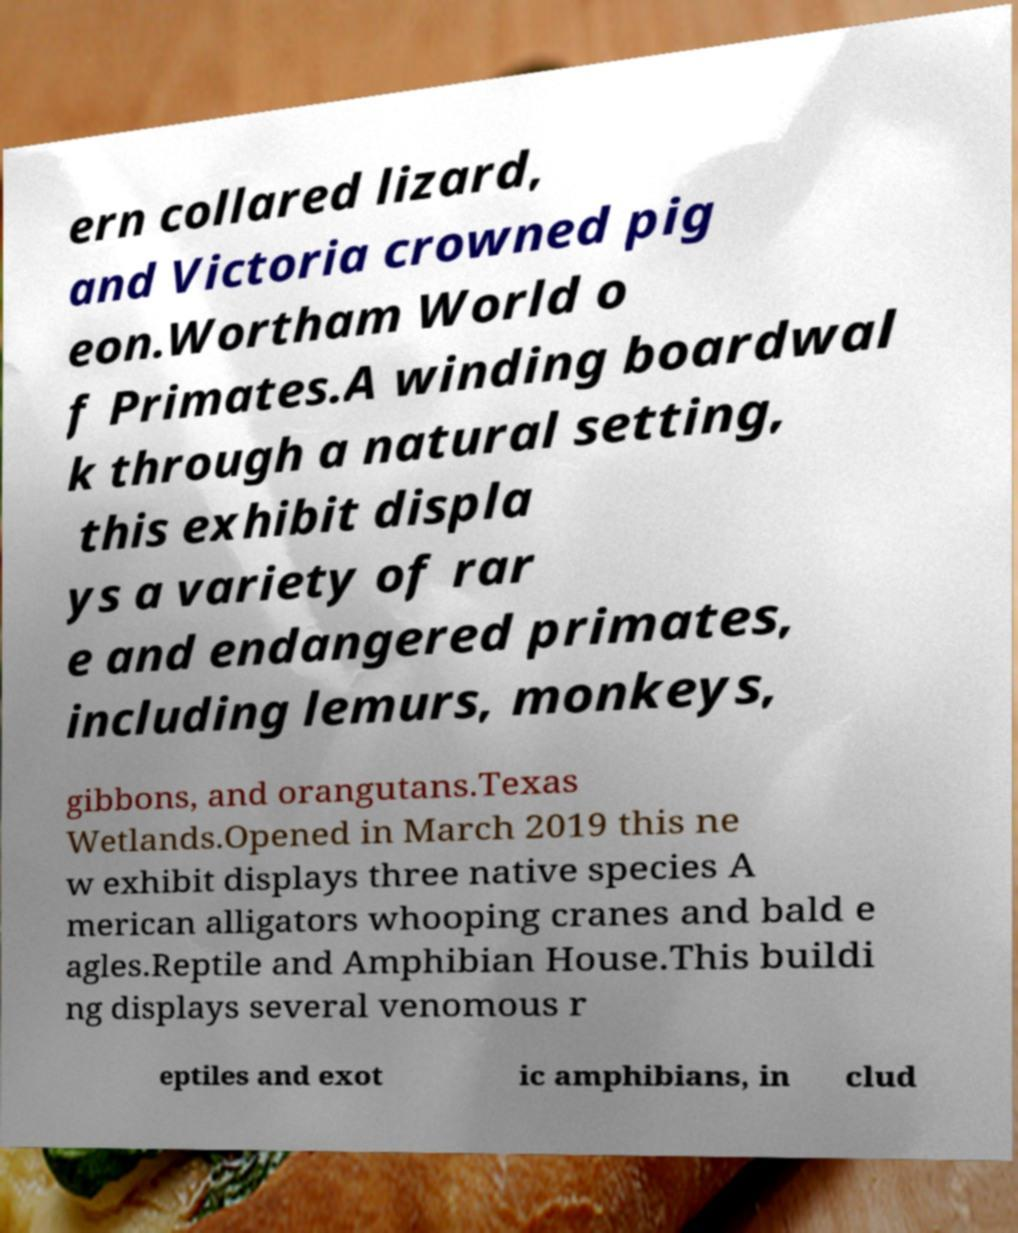For documentation purposes, I need the text within this image transcribed. Could you provide that? ern collared lizard, and Victoria crowned pig eon.Wortham World o f Primates.A winding boardwal k through a natural setting, this exhibit displa ys a variety of rar e and endangered primates, including lemurs, monkeys, gibbons, and orangutans.Texas Wetlands.Opened in March 2019 this ne w exhibit displays three native species A merican alligators whooping cranes and bald e agles.Reptile and Amphibian House.This buildi ng displays several venomous r eptiles and exot ic amphibians, in clud 